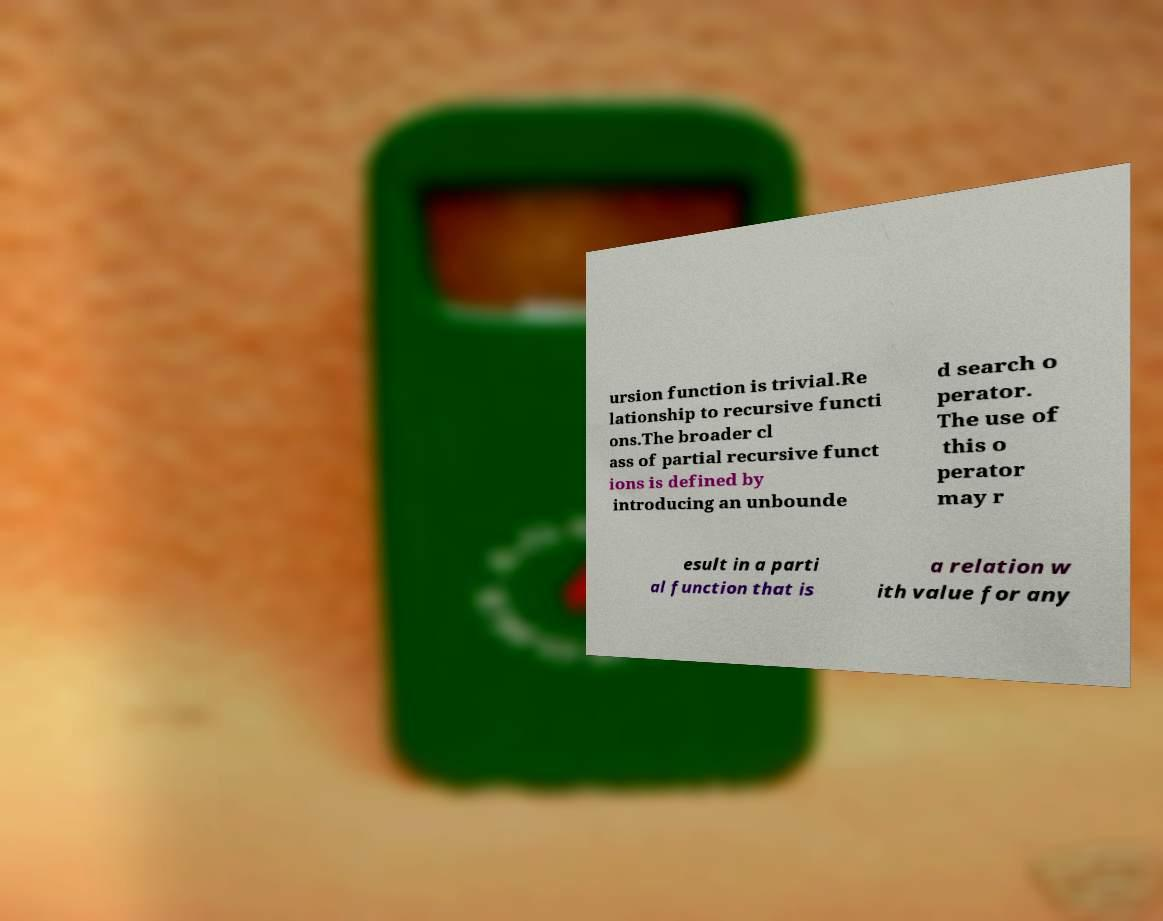Please read and relay the text visible in this image. What does it say? ursion function is trivial.Re lationship to recursive functi ons.The broader cl ass of partial recursive funct ions is defined by introducing an unbounde d search o perator. The use of this o perator may r esult in a parti al function that is a relation w ith value for any 